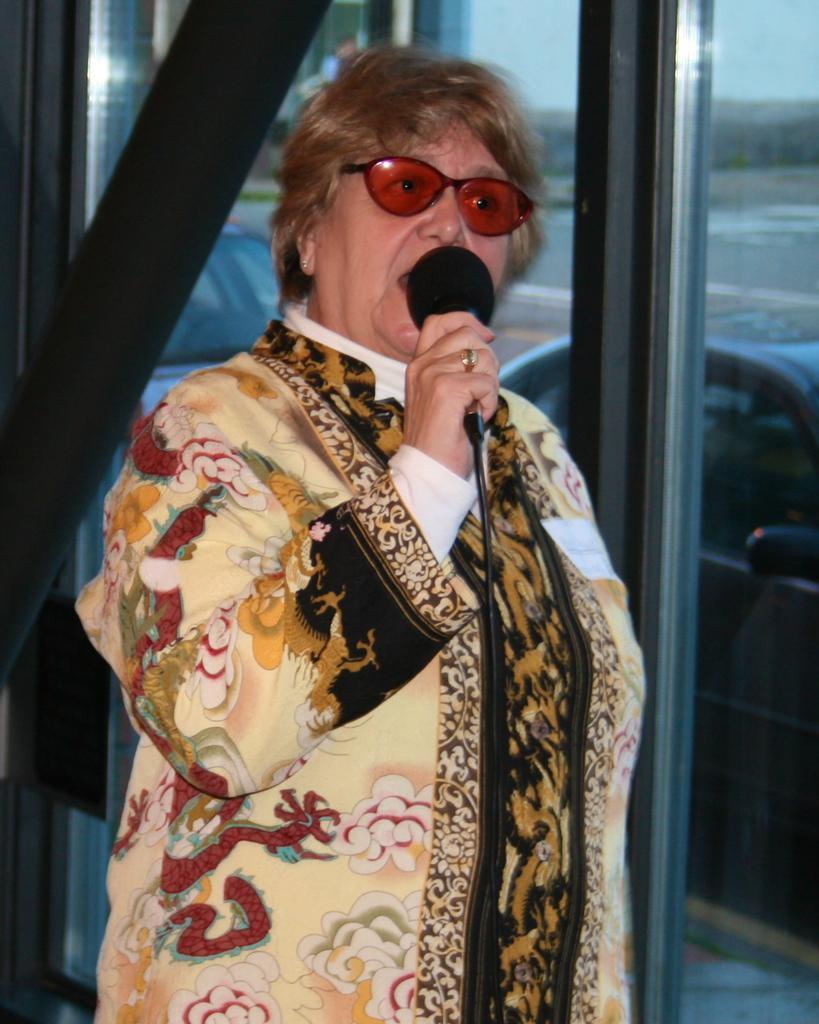In one or two sentences, can you explain what this image depicts? In this picture I can see a woman is standing. The woman is holding a microphone. The woman is wearing shades and a dress. In the background I can see vehicles. 